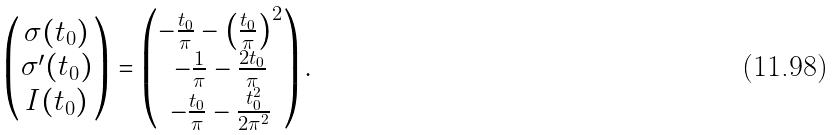<formula> <loc_0><loc_0><loc_500><loc_500>\begin{pmatrix} \sigma ( t _ { 0 } ) \\ \sigma ^ { \prime } ( t _ { 0 } ) \\ I ( t _ { 0 } ) \end{pmatrix} = \begin{pmatrix} - \frac { t _ { 0 } } { \pi } - \left ( \frac { t _ { 0 } } { \pi } \right ) ^ { 2 } \\ - \frac { 1 } { \pi } - \frac { 2 t _ { 0 } } { \pi } \\ - \frac { t _ { 0 } } { \pi } - \frac { t _ { 0 } ^ { 2 } } { 2 \pi ^ { 2 } } \end{pmatrix} .</formula> 